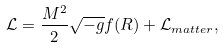Convert formula to latex. <formula><loc_0><loc_0><loc_500><loc_500>\mathcal { L } = \frac { M ^ { 2 } } { 2 } \sqrt { - g } f ( R ) + \mathcal { L } _ { m a t t e r } ,</formula> 